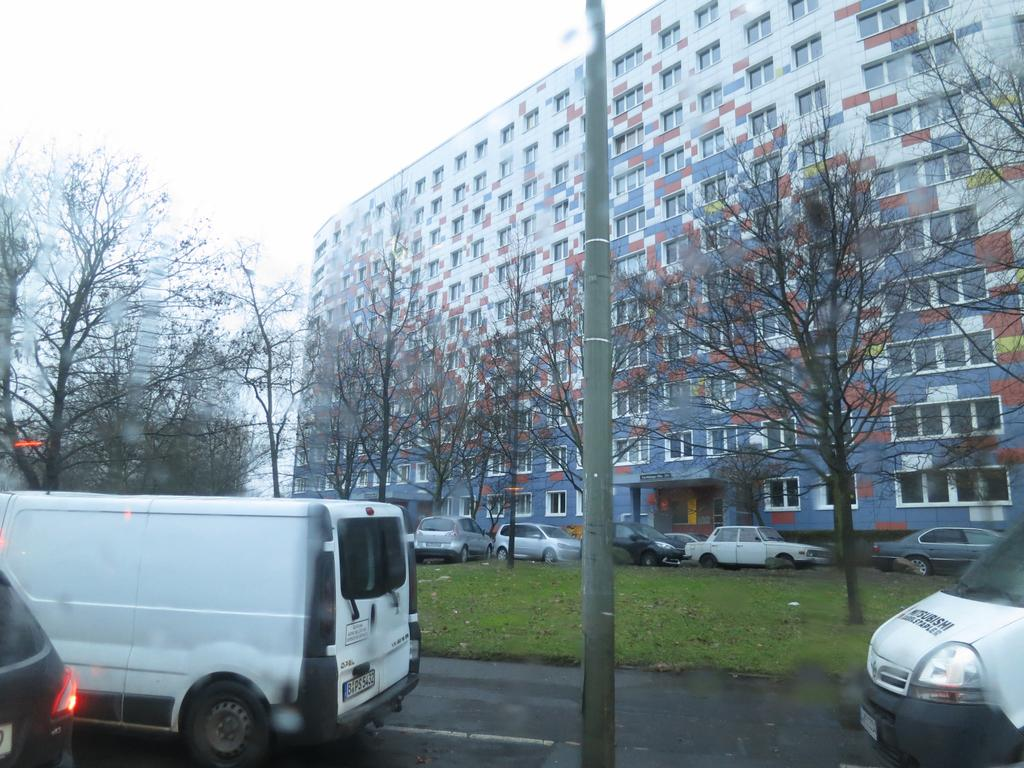What is happening on the road in the image? There are vehicles moving on the road in the image. What can be seen near the road in the image? There is a pole in the image. What is visible in the background of the image? There are trees, cars, and a big building in the background of the image. What type of toothbrush is hanging from the pole in the image? There is no toothbrush present in the image; it only features vehicles moving on the road, a pole, trees, cars, and a big building in the background. 